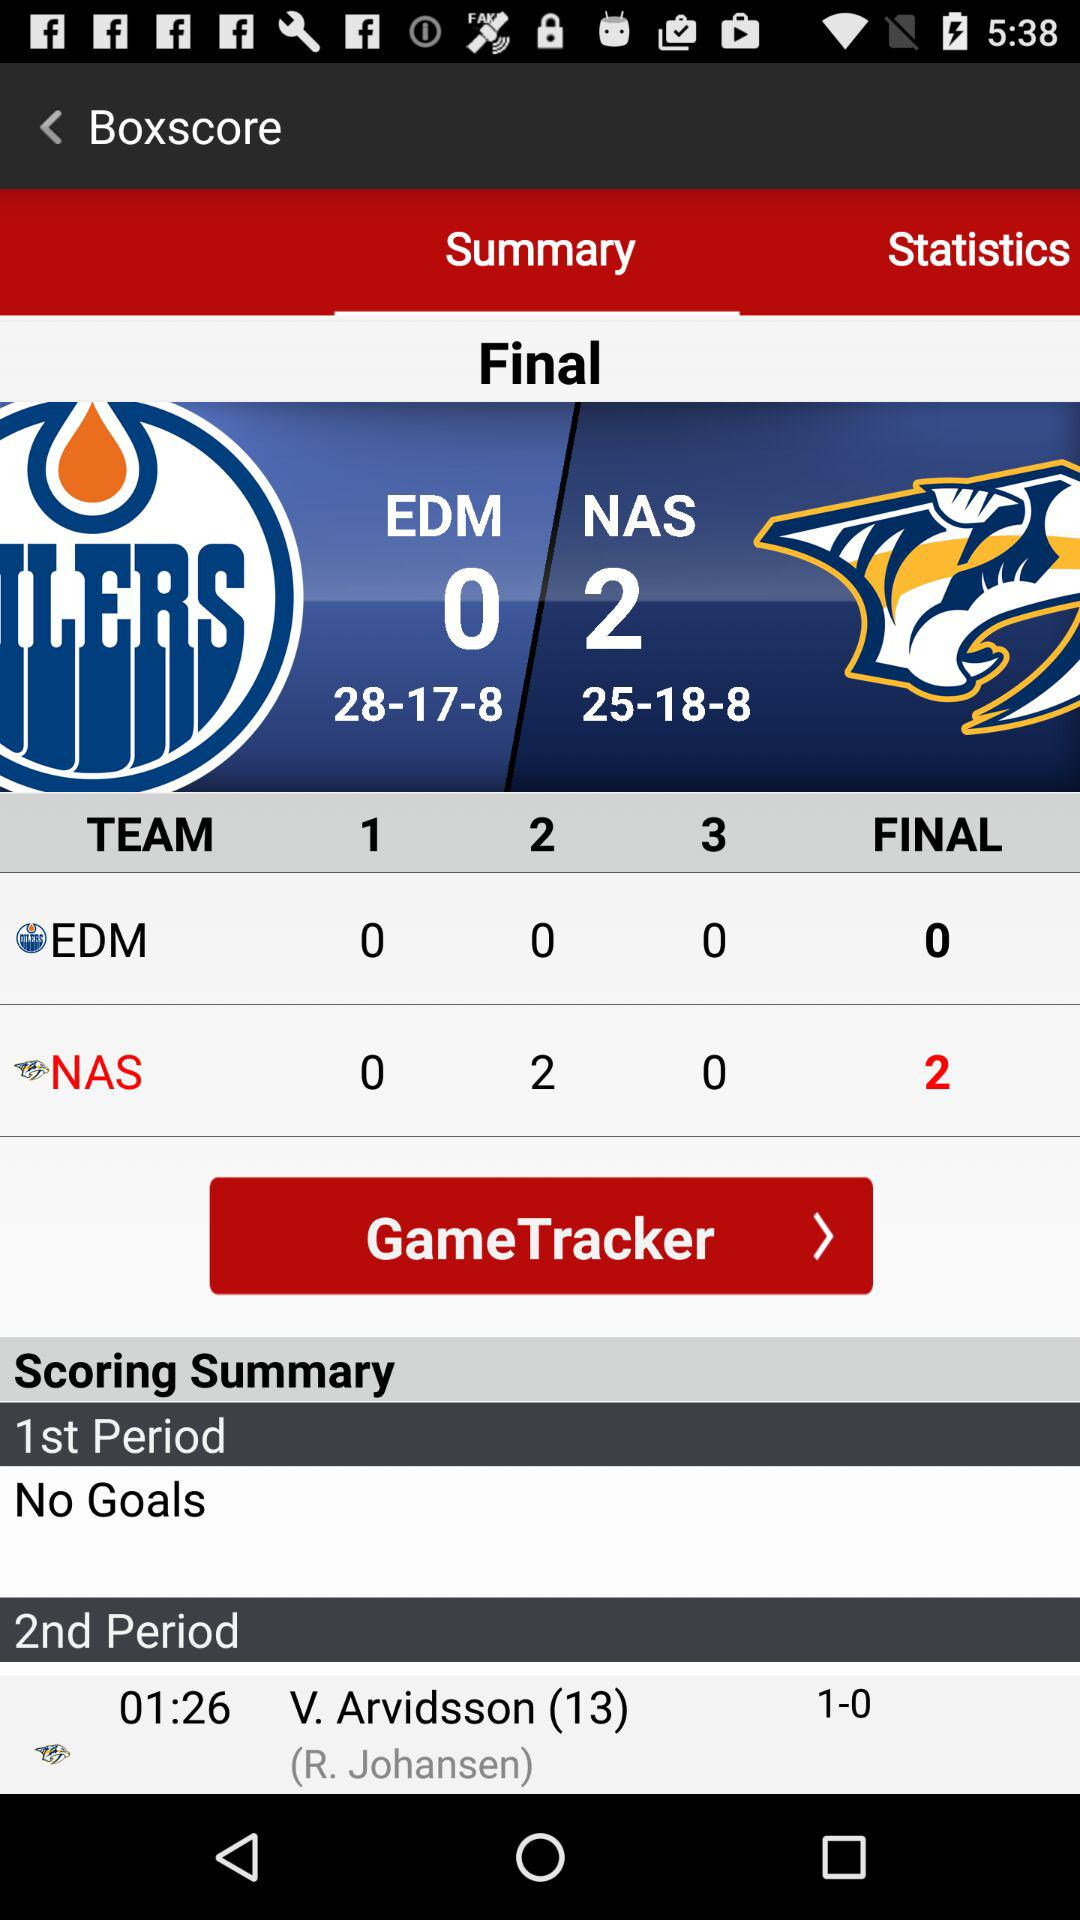What is the count of goal in 1st period? There are no goals. 